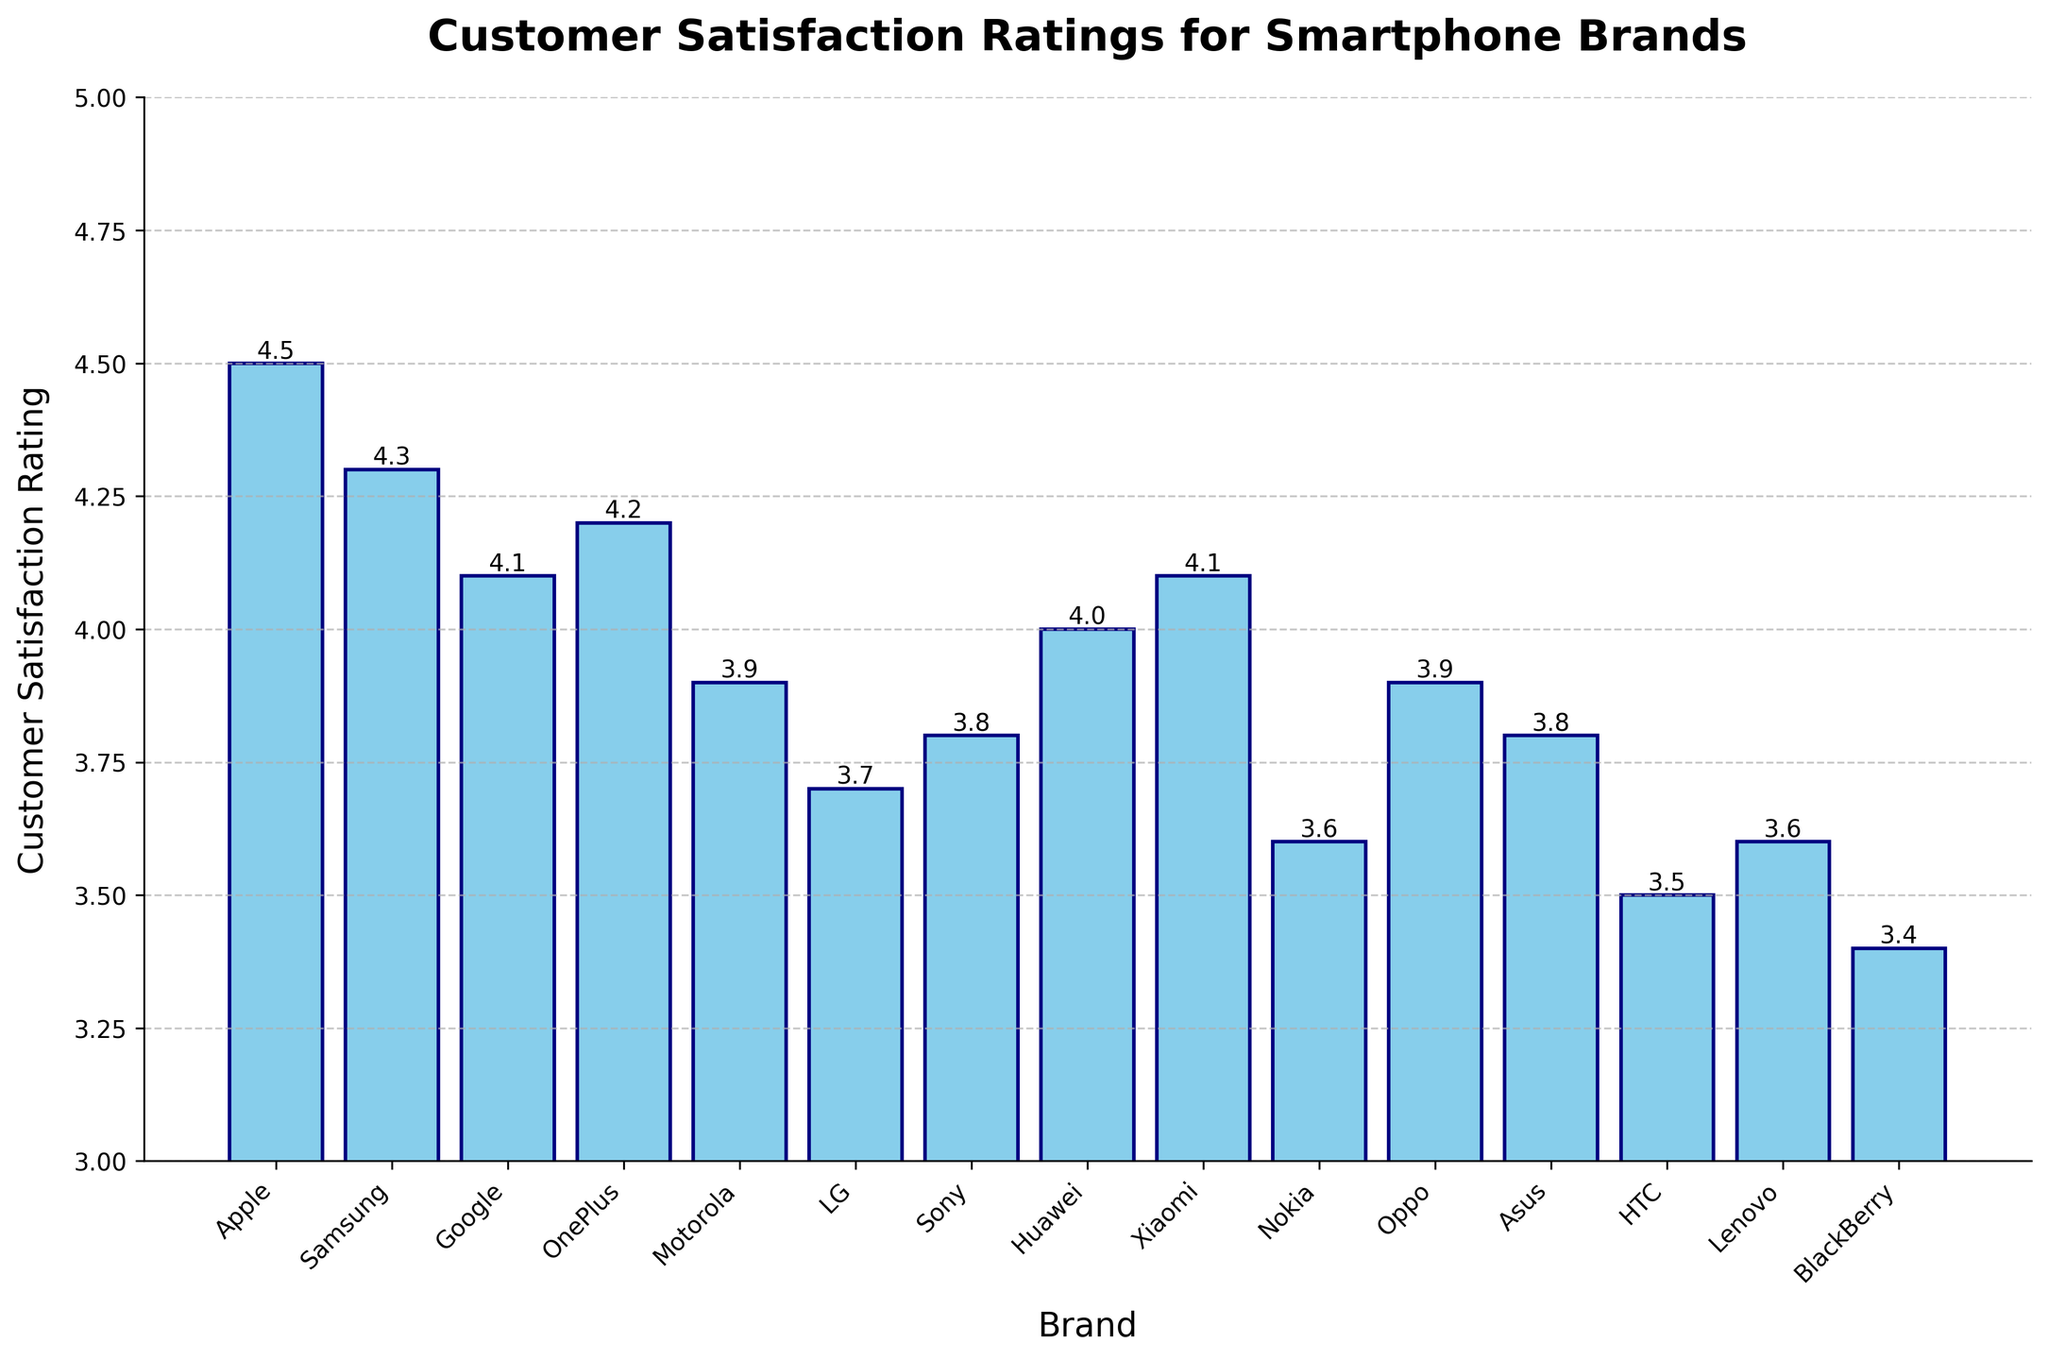Which brand has the highest customer satisfaction rating? The bar representing Apple is the tallest, indicating it has the highest rating.
Answer: Apple Which brand has the lowest customer satisfaction rating? The bar representing BlackBerry is the shortest, indicating it has the lowest rating.
Answer: BlackBerry Is Samsung's customer satisfaction rating higher than Google's? Compare the heights of the bars for Samsung and Google. Samsung's bar is taller.
Answer: Yes What is the average customer satisfaction rating for all brands? Sum the ratings of all brands and divide by the number of brands. (4.5 + 4.3 + 4.1 + 4.2 + 3.9 + 3.7 + 3.8 + 4.0 + 4.1 + 3.6 + 3.9 + 3.8 + 3.5 + 3.6 + 3.4) / 15 = 3.91
Answer: 3.91 How much higher is Apple’s satisfaction rating compared to Motorola’s? Subtract the rating of Motorola from Apple. 4.5 - 3.9 = 0.6
Answer: 0.6 Which two brands have identical customer satisfaction ratings? Compare the heights of all the bars to find similar ones. Xiaomi and Google both have ratings of 4.1.
Answer: Xiaomi and Google Is there any brand with a customer satisfaction rating exactly equal to 4.0? Look for a bar with height 4.0. Huawei's bar has a rating of 4.0.
Answer: Huawei Which brands have customer satisfaction ratings less than 4.0? Identify bars shorter than the 4.0 mark. Motorola, LG, Sony, Nokia, Asus, HTC, Lenovo, and BlackBerry have ratings less than 4.0.
Answer: Motorola, LG, Sony, Nokia, Asus, HTC, Lenovo, BlackBerry What is the total customer satisfaction rating for Apple, Samsung, and OnePlus combined? Sum the ratings of these brands. 4.5 (Apple) + 4.3 (Samsung) + 4.2 (OnePlus) = 13.0
Answer: 13.0 